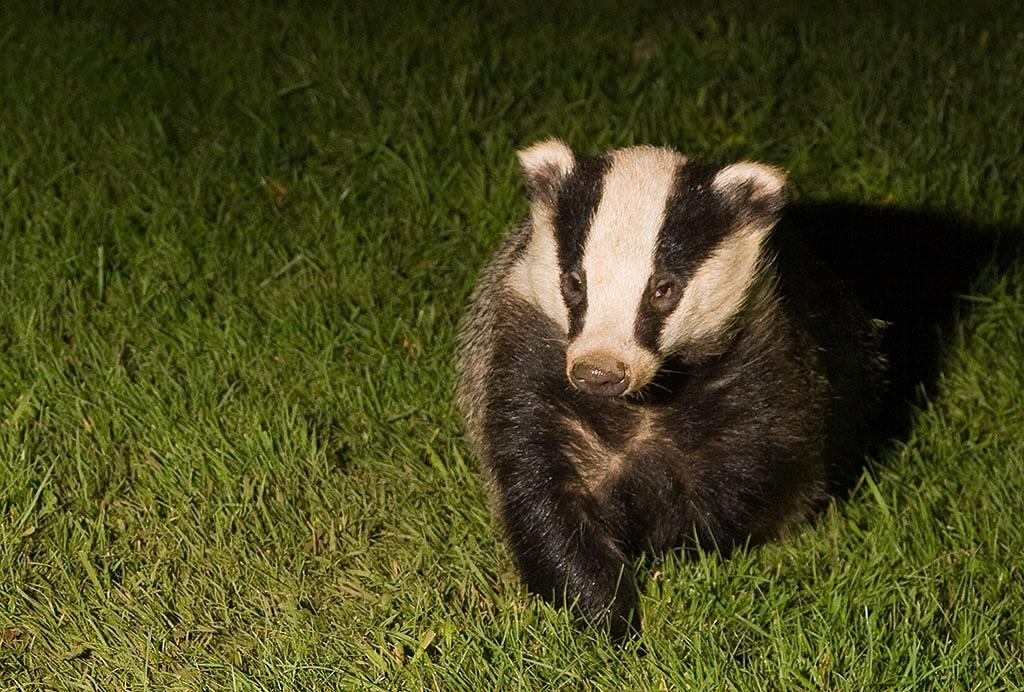What animal is present in the image? There is a badger in the image. Where is the badger located? The badger is on the grass. What type of soda is the badger drinking in the image? There is no soda present in the image; it features a badger on the grass. How does the grape move around in the image? There is no grape present in the image, so it cannot be determined how it might move. 